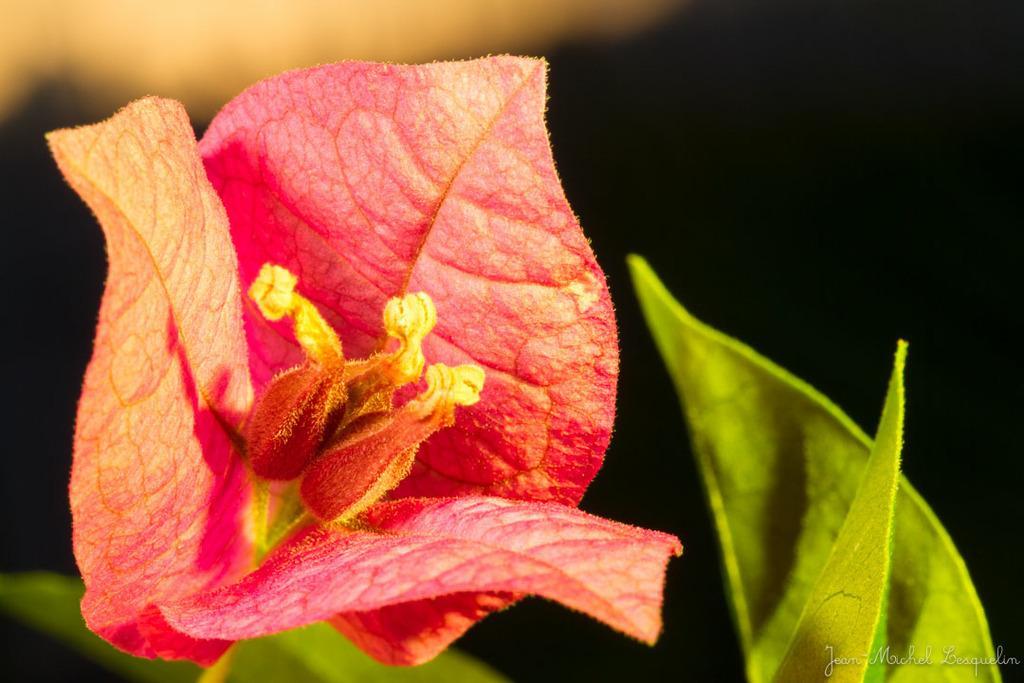Could you give a brief overview of what you see in this image? This is the picture of a flower. In this image there is a red color flower and there are leaves. In the bottom right there is a text. 